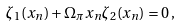Convert formula to latex. <formula><loc_0><loc_0><loc_500><loc_500>\zeta _ { 1 } ( x _ { n } ) + \Omega _ { \pi } x _ { n } \zeta _ { 2 } ( x _ { n } ) = 0 \, ,</formula> 